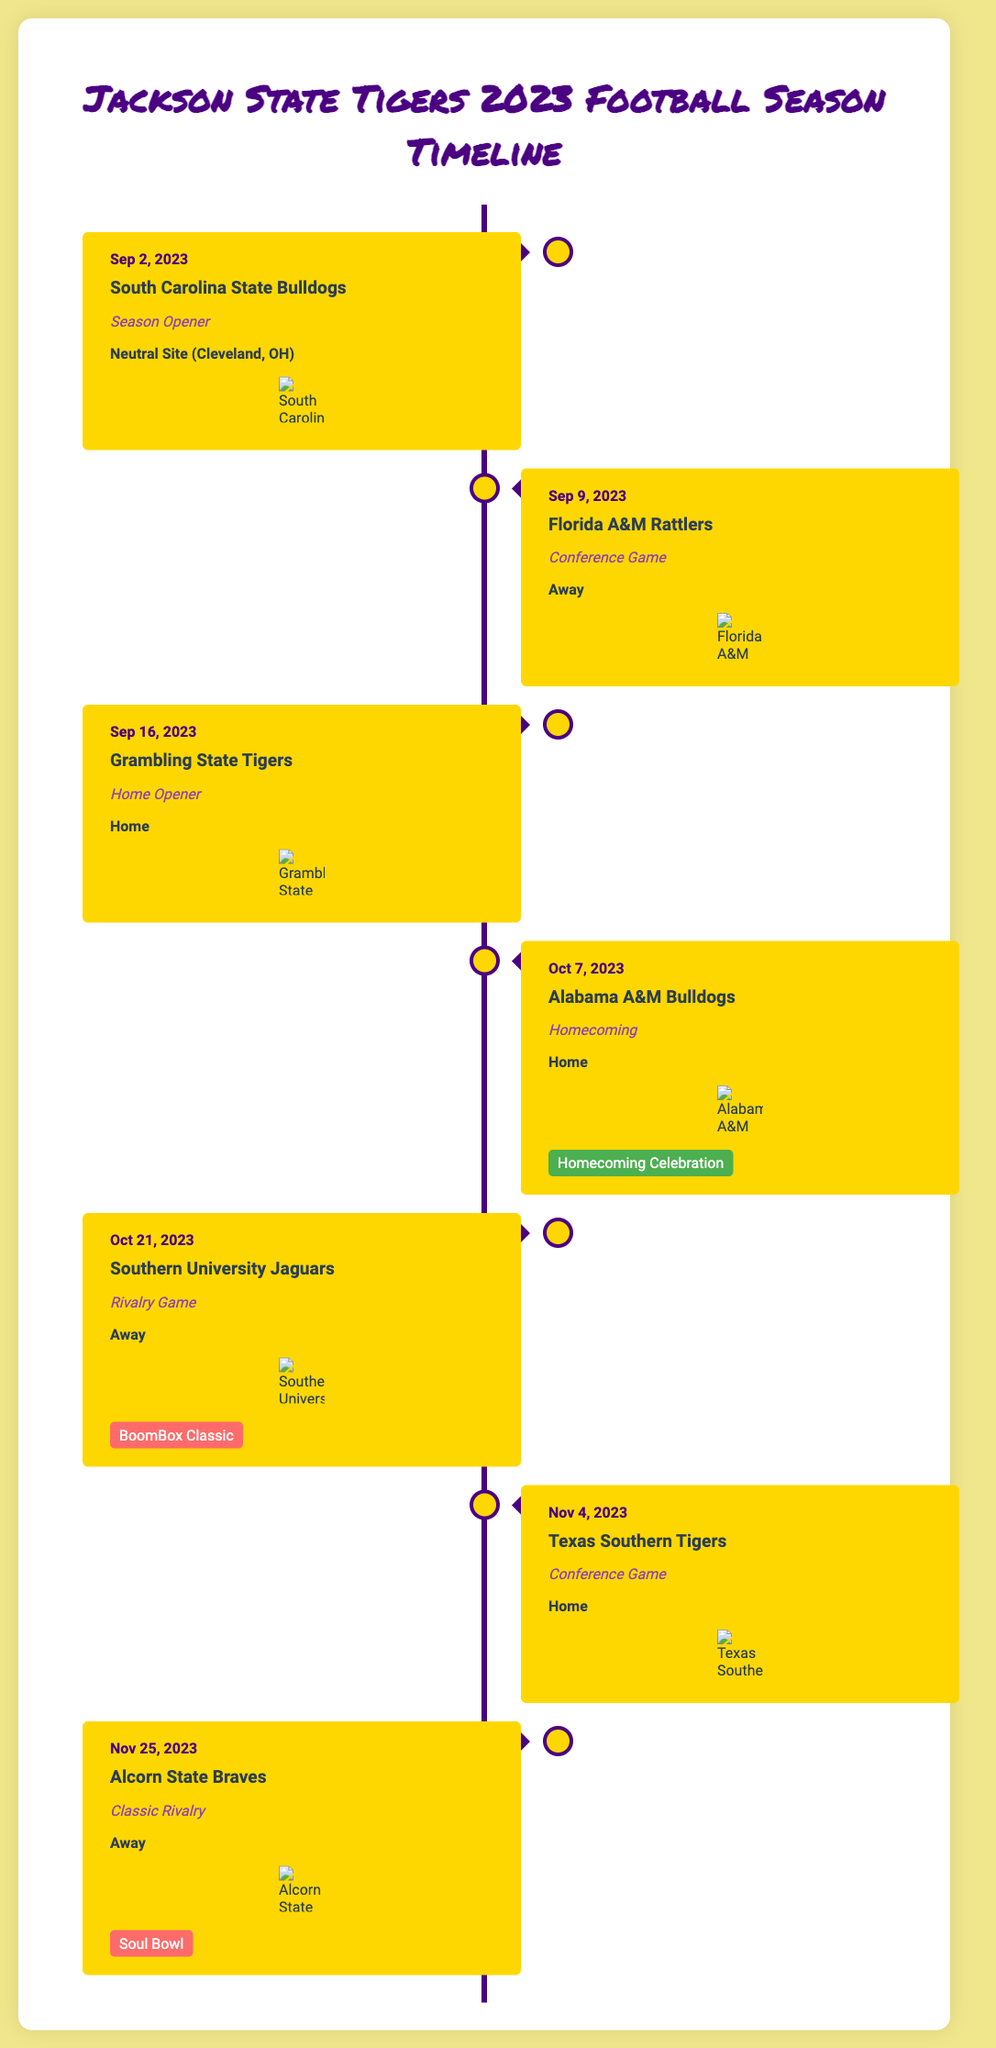What is the season opener date? The season opener is scheduled for September 2, 2023, against South Carolina State Bulldogs.
Answer: September 2, 2023 What type of game is the October 7, 2023 match? The game on October 7, 2023, against Alabama A&M Bulldogs is marked as Homecoming.
Answer: Homecoming Which team is the rival mentioned for the October 21, 2023 game? The game against Southern University Jaguars on October 21, 2023, is referred to as a rivalry game.
Answer: Southern University Jaguars What logo is displayed for the Grambling State Tigers? The document shows the logo for Grambling State Tigers in the home opener event.
Answer: Grambling State Tigers logo How many conference games are listed in the timeline? The timeline includes three conference games: Florida A&M Rattlers, Texas Southern Tigers, and Alabama A&M Bulldogs.
Answer: Three What is the last game of the season? The last game of the season is against Alcorn State Braves on November 25, 2023.
Answer: Alcorn State Braves What event takes place during the October 7 game against Alabama A&M? The event taking place during the October 7 game is the Homecoming celebration.
Answer: Homecoming Celebration When is the BoomBox Classic scheduled? The BoomBox Classic is scheduled for October 21, 2023.
Answer: October 21, 2023 Where is the season opener being held? The season opener against South Carolina State Bulldogs is at a neutral site in Cleveland, OH.
Answer: Cleveland, OH 